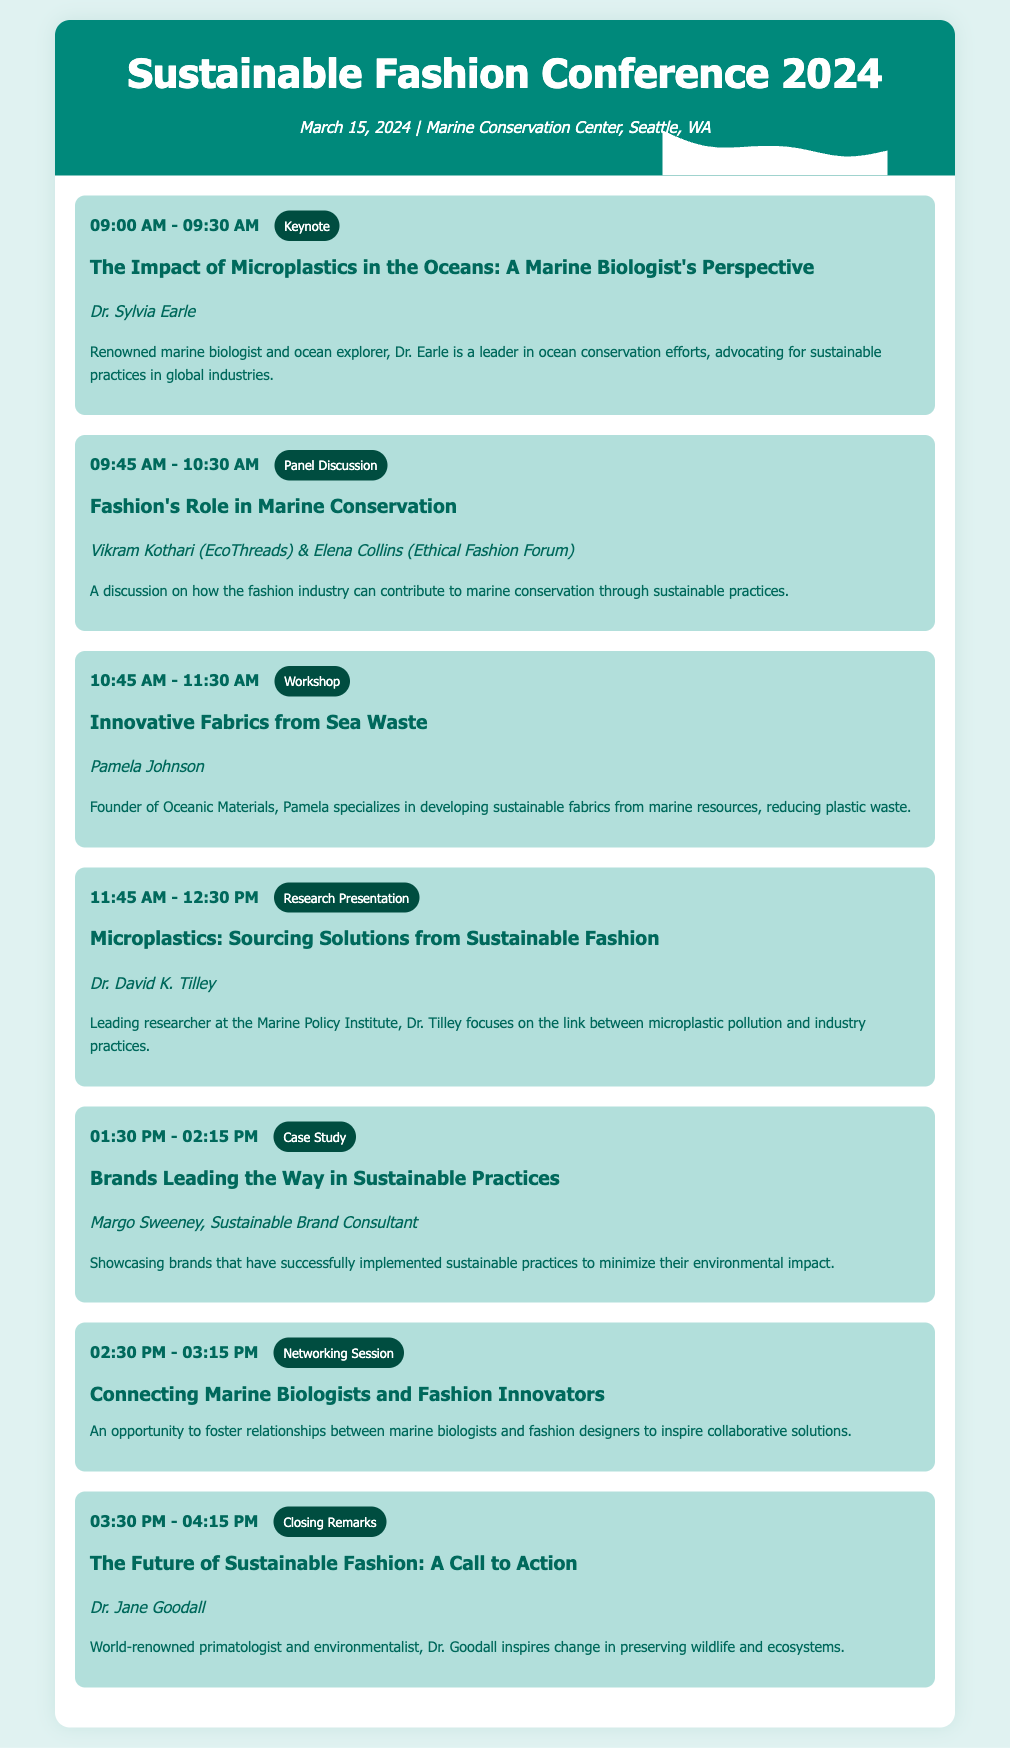What is the date of the conference? The date of the conference is mentioned at the top of the document.
Answer: March 15, 2024 Who is the speaker for the keynote session? The keynote session includes the name of the speaker in the session details.
Answer: Dr. Sylvia Earle What type of session is scheduled at 09:45 AM? The type of session can be found alongside the session time in the agenda.
Answer: Panel Discussion What is the title of the final session? The title of the closing remarks session is listed in the last session details.
Answer: The Future of Sustainable Fashion: A Call to Action Who is leading the workshop on innovative fabrics? The speaker's name is provided in the workshop session details.
Answer: Pamela Johnson What is the focus of Dr. David K. Tilley's research presentation? The general subject of Dr. Tilley's presentation is included in the session description.
Answer: Microplastic pollution and industry practices How long is the Networking Session? The duration can be inferred based on the session timing presented in the agenda.
Answer: 45 Minutes Which organization is represented in the panel discussion? The panel discussion lists the organizations of its speakers, which are noted in the session description.
Answer: EcoThreads and Ethical Fashion Forum 